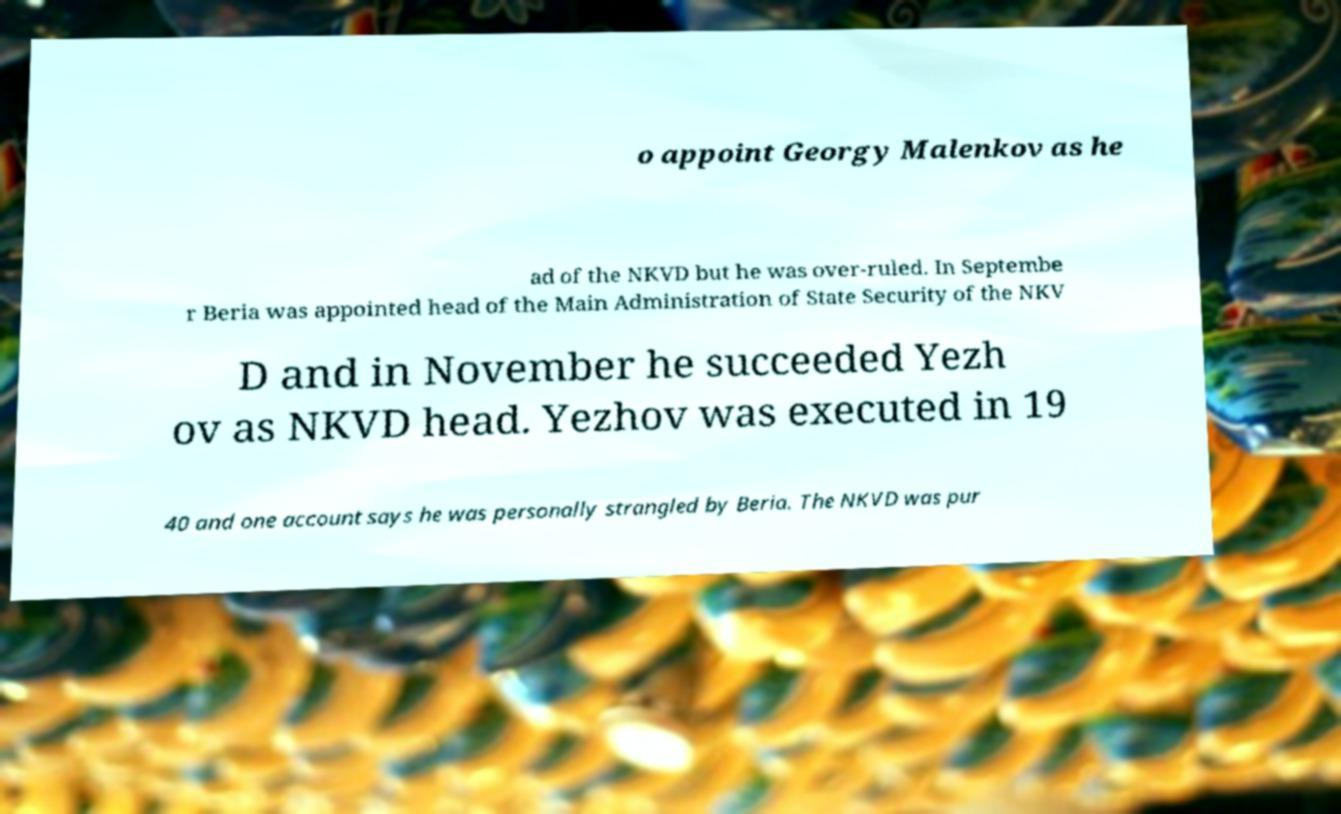Please read and relay the text visible in this image. What does it say? o appoint Georgy Malenkov as he ad of the NKVD but he was over-ruled. In Septembe r Beria was appointed head of the Main Administration of State Security of the NKV D and in November he succeeded Yezh ov as NKVD head. Yezhov was executed in 19 40 and one account says he was personally strangled by Beria. The NKVD was pur 